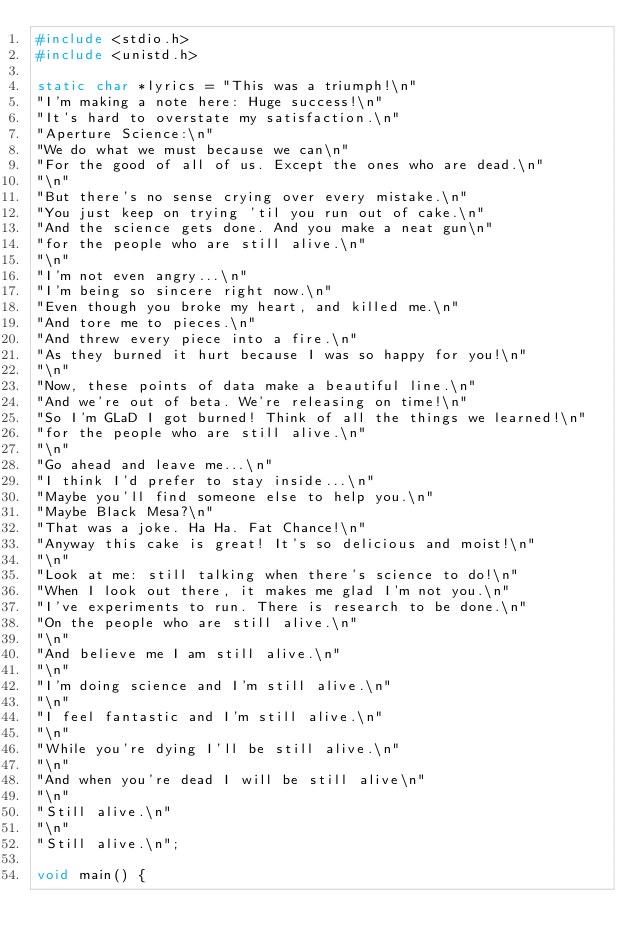Convert code to text. <code><loc_0><loc_0><loc_500><loc_500><_C_>#include <stdio.h>
#include <unistd.h>

static char *lyrics = "This was a triumph!\n"
"I'm making a note here: Huge success!\n"
"It's hard to overstate my satisfaction.\n"
"Aperture Science:\n"
"We do what we must because we can\n"
"For the good of all of us. Except the ones who are dead.\n"
"\n"
"But there's no sense crying over every mistake.\n"
"You just keep on trying 'til you run out of cake.\n"
"And the science gets done. And you make a neat gun\n"
"for the people who are still alive.\n"
"\n"
"I'm not even angry...\n"
"I'm being so sincere right now.\n"
"Even though you broke my heart, and killed me.\n"
"And tore me to pieces.\n"
"And threw every piece into a fire.\n"
"As they burned it hurt because I was so happy for you!\n"
"\n"
"Now, these points of data make a beautiful line.\n"
"And we're out of beta. We're releasing on time!\n"
"So I'm GLaD I got burned! Think of all the things we learned!\n"
"for the people who are still alive.\n"
"\n"
"Go ahead and leave me...\n"
"I think I'd prefer to stay inside...\n"
"Maybe you'll find someone else to help you.\n"
"Maybe Black Mesa?\n"
"That was a joke. Ha Ha. Fat Chance!\n"
"Anyway this cake is great! It's so delicious and moist!\n"
"\n"
"Look at me: still talking when there's science to do!\n"
"When I look out there, it makes me glad I'm not you.\n"
"I've experiments to run. There is research to be done.\n"
"On the people who are still alive.\n"
"\n"
"And believe me I am still alive.\n"
"\n"
"I'm doing science and I'm still alive.\n"
"\n"
"I feel fantastic and I'm still alive.\n"
"\n"
"While you're dying I'll be still alive.\n"
"\n"
"And when you're dead I will be still alive\n"
"\n"
"Still alive.\n"
"\n"
"Still alive.\n";

void main() {</code> 